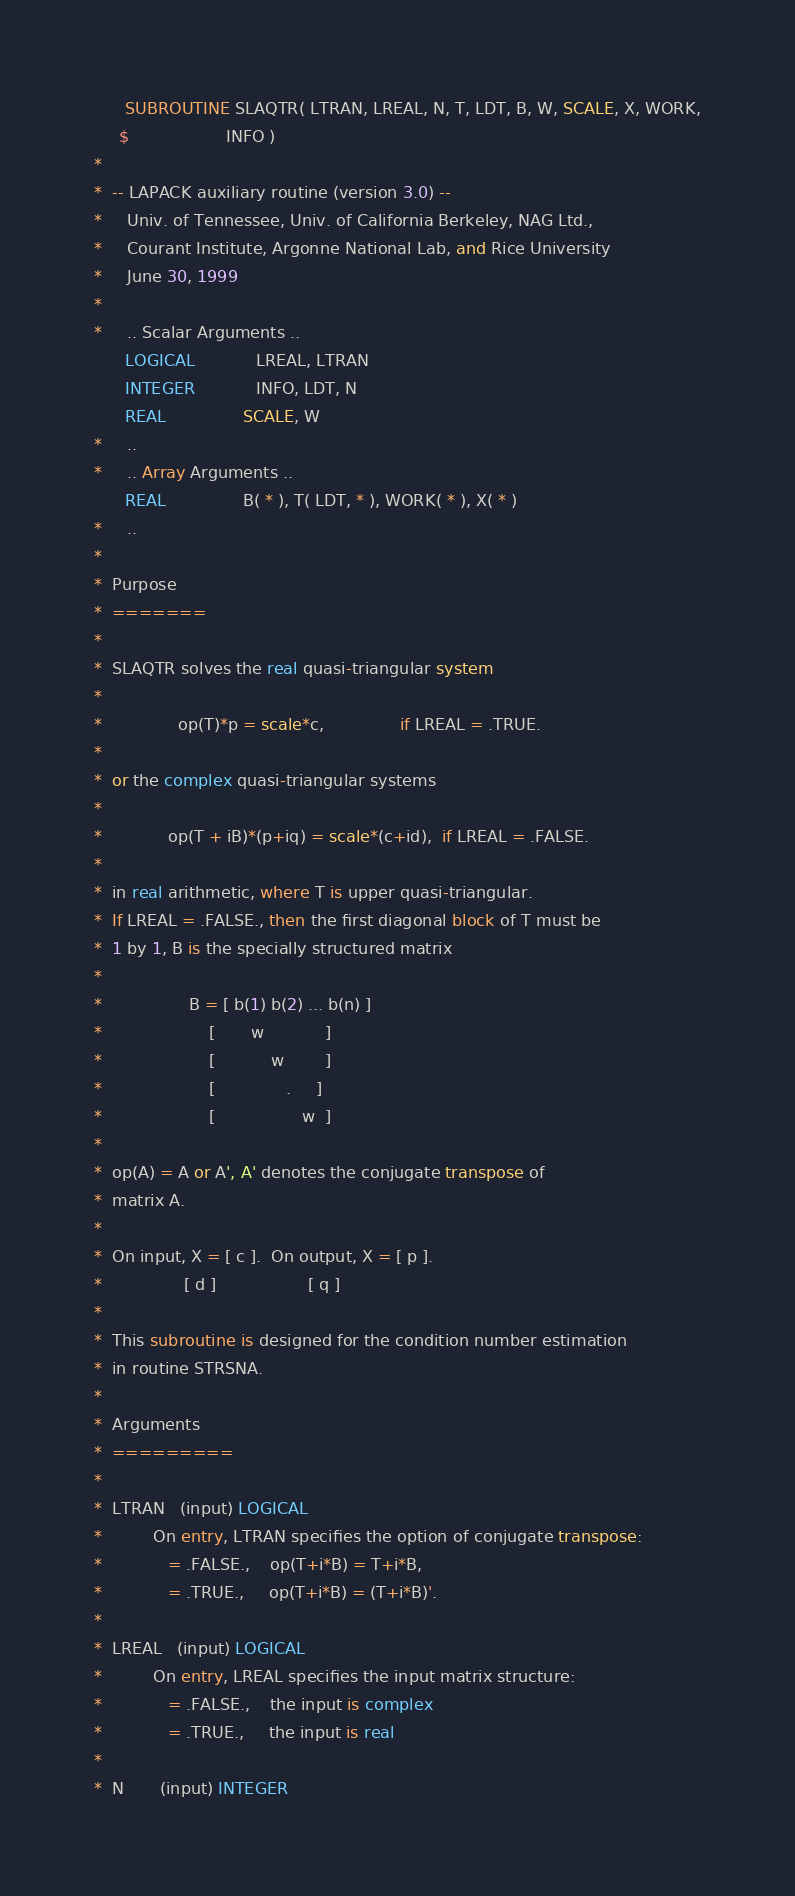<code> <loc_0><loc_0><loc_500><loc_500><_FORTRAN_>      SUBROUTINE SLAQTR( LTRAN, LREAL, N, T, LDT, B, W, SCALE, X, WORK,
     $                   INFO )
*
*  -- LAPACK auxiliary routine (version 3.0) --
*     Univ. of Tennessee, Univ. of California Berkeley, NAG Ltd.,
*     Courant Institute, Argonne National Lab, and Rice University
*     June 30, 1999
*
*     .. Scalar Arguments ..
      LOGICAL            LREAL, LTRAN
      INTEGER            INFO, LDT, N
      REAL               SCALE, W
*     ..
*     .. Array Arguments ..
      REAL               B( * ), T( LDT, * ), WORK( * ), X( * )
*     ..
*
*  Purpose
*  =======
*
*  SLAQTR solves the real quasi-triangular system
*
*               op(T)*p = scale*c,               if LREAL = .TRUE.
*
*  or the complex quasi-triangular systems
*
*             op(T + iB)*(p+iq) = scale*(c+id),  if LREAL = .FALSE.
*
*  in real arithmetic, where T is upper quasi-triangular.
*  If LREAL = .FALSE., then the first diagonal block of T must be
*  1 by 1, B is the specially structured matrix
*
*                 B = [ b(1) b(2) ... b(n) ]
*                     [       w            ]
*                     [           w        ]
*                     [              .     ]
*                     [                 w  ]
*
*  op(A) = A or A', A' denotes the conjugate transpose of
*  matrix A.
*
*  On input, X = [ c ].  On output, X = [ p ].
*                [ d ]                  [ q ]
*
*  This subroutine is designed for the condition number estimation
*  in routine STRSNA.
*
*  Arguments
*  =========
*
*  LTRAN   (input) LOGICAL
*          On entry, LTRAN specifies the option of conjugate transpose:
*             = .FALSE.,    op(T+i*B) = T+i*B,
*             = .TRUE.,     op(T+i*B) = (T+i*B)'.
*
*  LREAL   (input) LOGICAL
*          On entry, LREAL specifies the input matrix structure:
*             = .FALSE.,    the input is complex
*             = .TRUE.,     the input is real
*
*  N       (input) INTEGER</code> 